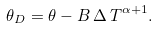Convert formula to latex. <formula><loc_0><loc_0><loc_500><loc_500>\theta _ { D } = \theta - B \, { \Delta \, T } ^ { \alpha + 1 } .</formula> 